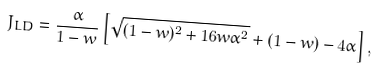<formula> <loc_0><loc_0><loc_500><loc_500>J _ { L D } = \frac { \alpha } { 1 - w } \left [ \sqrt { ( 1 - w ) ^ { 2 } + 1 6 w \alpha ^ { 2 } } + ( 1 - w ) - 4 \alpha \right ] ,</formula> 